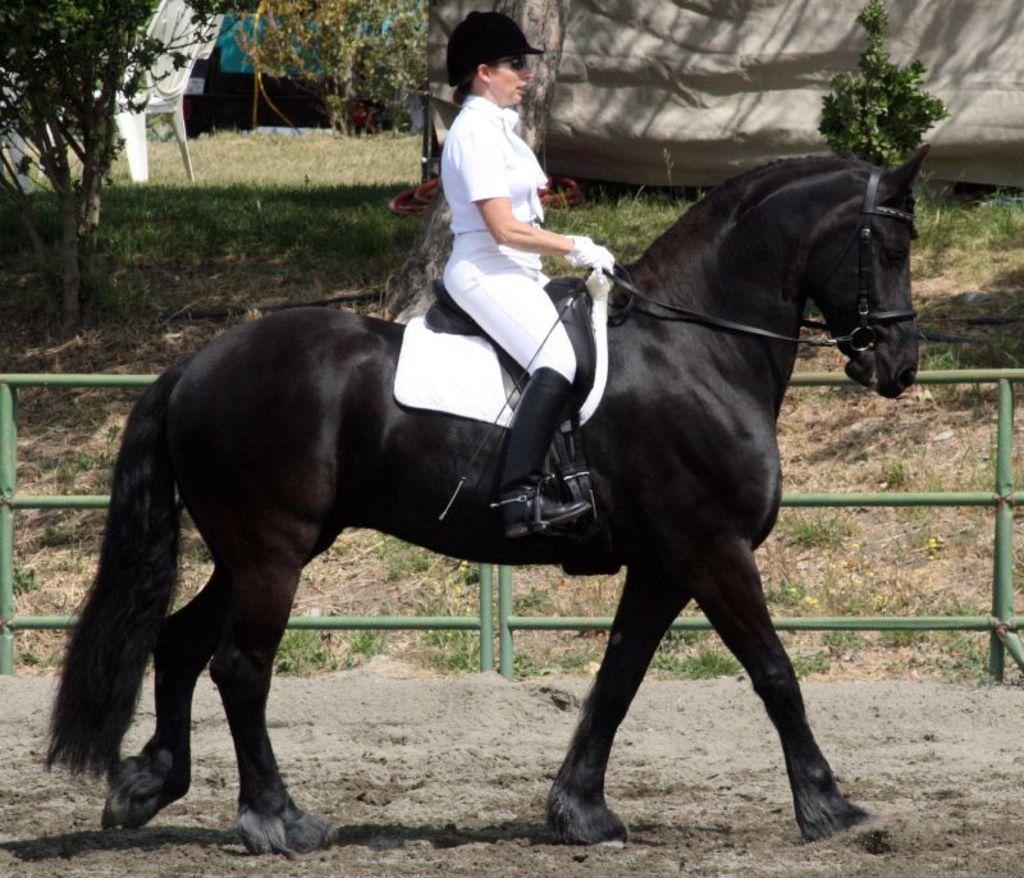Who is the main subject in the image? There is a woman in the image. What is the woman doing in the image? The woman is riding a horse. What can be seen in the background of the image? There are trees near the woman. How many sinks can be seen in the image? There are no sinks present in the image. What type of giants are visible in the image? There are no giants present in the image. 